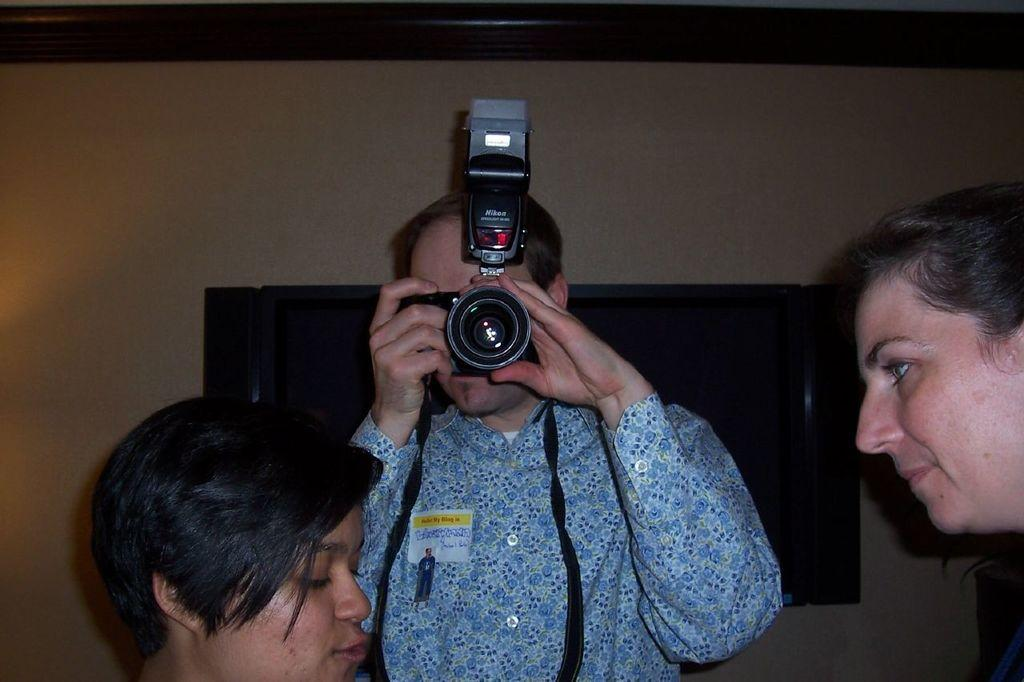What is the person in the image holding? The person in the image is holding a camera. Who are the other people in the image? There are two women in front of the person with the camera. What can be seen in the background of the image? There is a wall visible in the background of the image. What type of net is being used by the person holding the camera? There is no net present in the image; the person is holding a camera. How many pizzas are on the table in the image? There is no table or pizzas present in the image. 